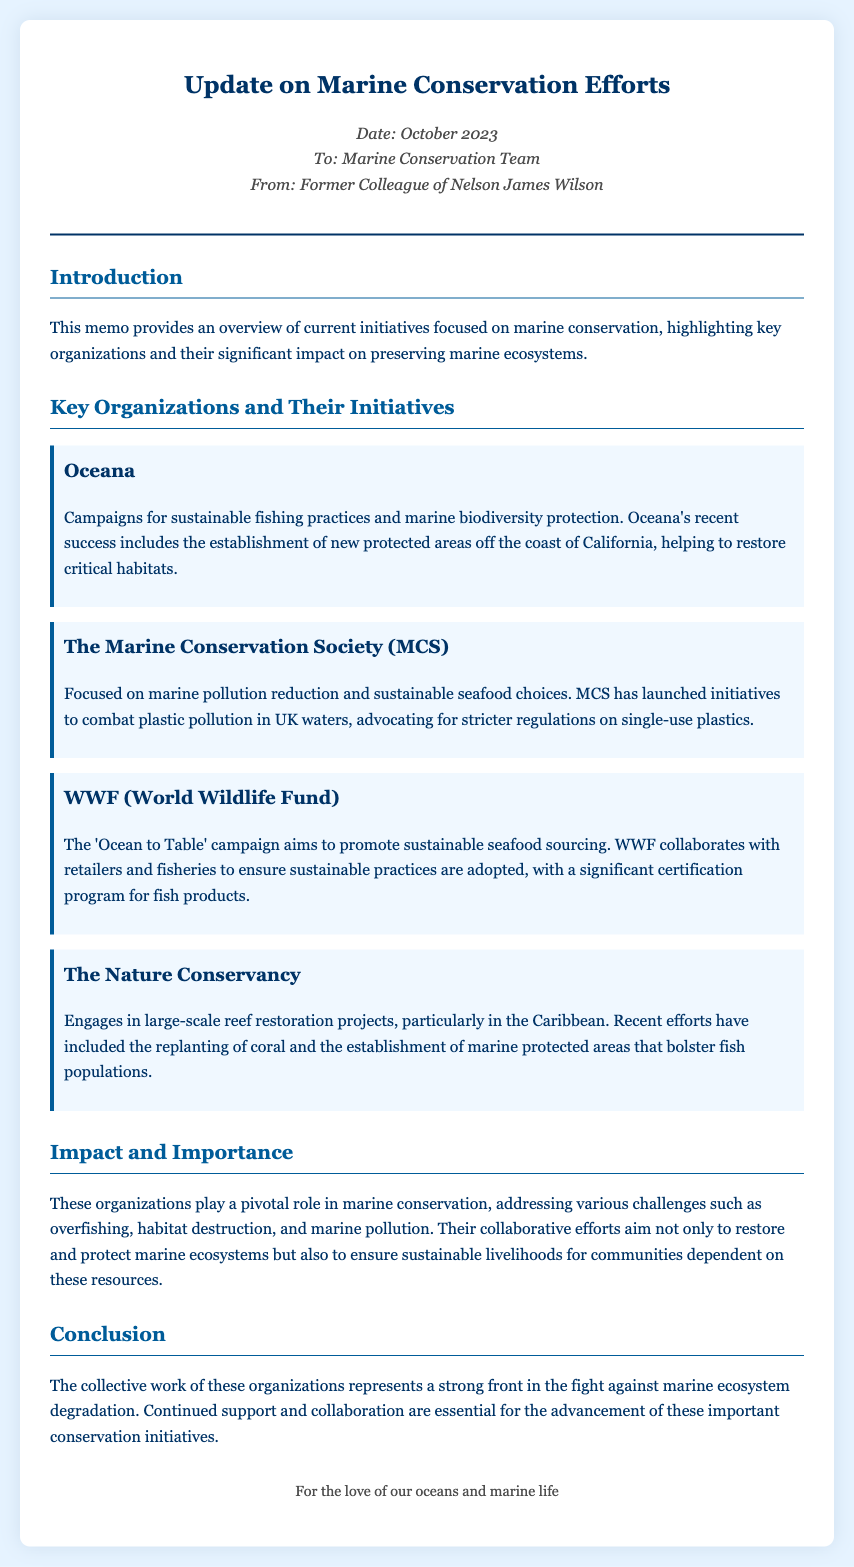What is the title of the memo? The title is stated at the beginning of the document and summarizes the main topic.
Answer: Update on Marine Conservation Efforts Who is the memo addressed to? The recipient of the memo is mentioned in the introductory section.
Answer: Marine Conservation Team What organization focuses on sustainable fishing practices? The document specifically mentions this organization and its initiatives.
Answer: Oceana What is the latest initiative by The Marine Conservation Society? The document highlights specific actions taken by this organization to address an important issue.
Answer: Combat plastic pollution What campaign does WWF promote? This campaign's goal is detailed in a section discussing the organization's activities.
Answer: Ocean to Table What recent action did The Nature Conservancy undertake? The document provides specific examples of the organization's efforts in reef restoration.
Answer: Reef restoration projects What overarching challenges are addressed by these organizations? The memo specifies these challenges in the context of marine conservation efforts.
Answer: Overfishing, habitat destruction, and marine pollution How many key organizations are highlighted in the memo? The total within the document indicates the number of organizations discussed.
Answer: Four What is the objective of the collective work mentioned in the memo? The memo outlines the main goal of these organizations in its conclusion.
Answer: Marine ecosystem protection 